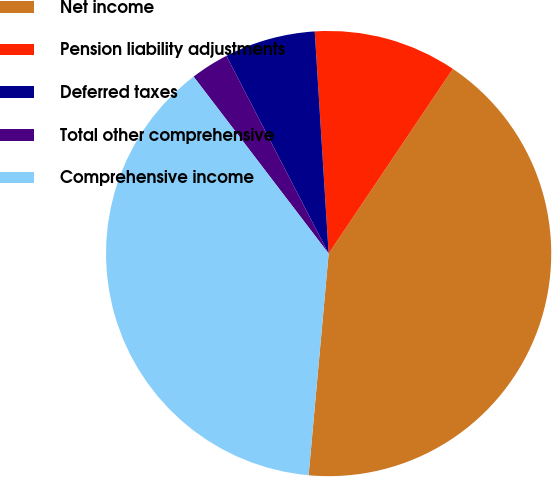Convert chart to OTSL. <chart><loc_0><loc_0><loc_500><loc_500><pie_chart><fcel>Net income<fcel>Pension liability adjustments<fcel>Deferred taxes<fcel>Total other comprehensive<fcel>Comprehensive income<nl><fcel>42.01%<fcel>10.42%<fcel>6.6%<fcel>2.78%<fcel>38.19%<nl></chart> 